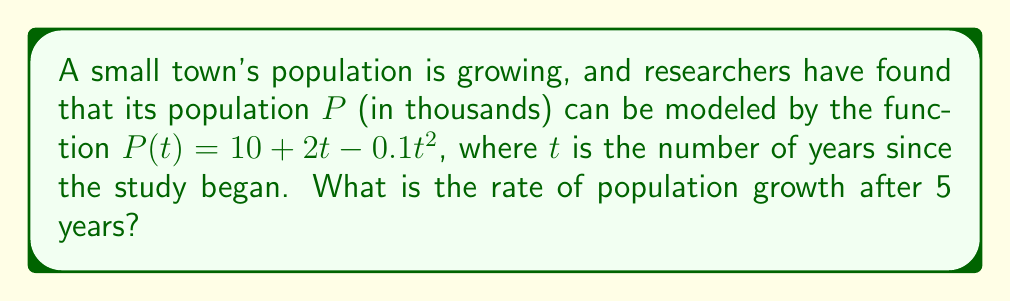Could you help me with this problem? To find the rate of population growth after 5 years, we need to follow these steps:

1. The rate of change in population is given by the derivative of the population function $P(t)$.

2. Let's find the derivative of $P(t)$:
   $$P(t) = 10 + 2t - 0.1t^2$$
   $$\frac{dP}{dt} = 2 - 0.2t$$

3. This derivative $\frac{dP}{dt}$ represents the instantaneous rate of change in population at any time $t$.

4. To find the rate of growth after 5 years, we need to evaluate $\frac{dP}{dt}$ at $t = 5$:
   $$\frac{dP}{dt}\bigg|_{t=5} = 2 - 0.2(5) = 2 - 1 = 1$$

5. The result is in thousands of people per year, so we need to convert it to people per year.

Therefore, after 5 years, the population is growing at a rate of 1,000 people per year.
Answer: 1,000 people/year 